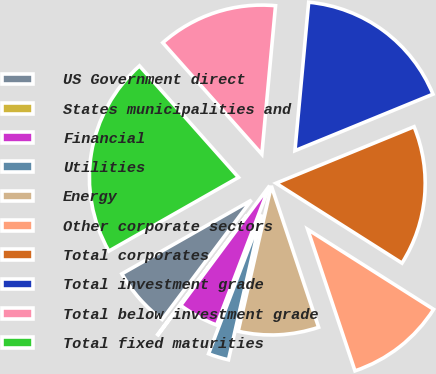<chart> <loc_0><loc_0><loc_500><loc_500><pie_chart><fcel>US Government direct<fcel>States municipalities and<fcel>Financial<fcel>Utilities<fcel>Energy<fcel>Other corporate sectors<fcel>Total corporates<fcel>Total investment grade<fcel>Total below investment grade<fcel>Total fixed maturities<nl><fcel>6.54%<fcel>0.06%<fcel>4.38%<fcel>2.22%<fcel>8.7%<fcel>10.86%<fcel>15.18%<fcel>17.34%<fcel>13.02%<fcel>21.66%<nl></chart> 